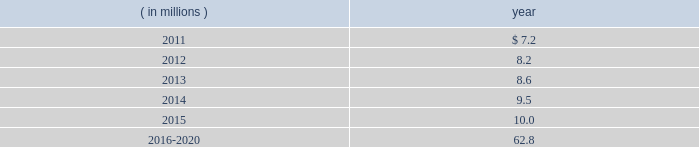The company expects to amortize $ 1.7 million of actuarial loss from accumulated other comprehensive income ( loss ) into net periodic benefit costs in 2011 .
At december 31 , 2010 , anticipated benefit payments from the plan in future years are as follows: .
Savings plans .
Cme maintains a defined contribution savings plan pursuant to section 401 ( k ) of the internal revenue code , whereby all u.s .
Employees are participants and have the option to contribute to this plan .
Cme matches employee contributions up to 3% ( 3 % ) of the employee 2019s base salary and may make additional discretionary contributions of up to 2% ( 2 % ) of base salary .
In addition , certain cme london-based employees are eligible to participate in a defined contribution plan .
For cme london-based employees , the plan provides for company contributions of 10% ( 10 % ) of earnings and does not have any vesting requirements .
Salary and cash bonuses paid are included in the definition of earnings .
Aggregate expense for all of the defined contribution savings plans amounted to $ 6.3 million , $ 5.2 million and $ 5.8 million in 2010 , 2009 and 2008 , respectively .
Cme non-qualified plans .
Cme maintains non-qualified plans , under which participants may make assumed investment choices with respect to amounts contributed on their behalf .
Although not required to do so , cme invests such contributions in assets that mirror the assumed investment choices .
The balances in these plans are subject to the claims of general creditors of the exchange and totaled $ 28.8 million and $ 23.4 million at december 31 , 2010 and 2009 , respectively .
Although the value of the plans is recorded as an asset in the consolidated balance sheets , there is an equal and offsetting liability .
The investment results of these plans have no impact on net income as the investment results are recorded in equal amounts to both investment income and compensation and benefits expense .
Supplemental savings plan 2014cme maintains a supplemental plan to provide benefits for employees who have been impacted by statutory limits under the provisions of the qualified pension and savings plan .
All cme employees hired prior to january 1 , 2007 are immediately vested in their supplemental plan benefits .
All cme employees hired on or after january 1 , 2007 are subject to the vesting requirements of the underlying qualified plans .
Total expense for the supplemental plan was $ 0.9 million , $ 0.7 million and $ 1.3 million for 2010 , 2009 and 2008 , respectively .
Deferred compensation plan 2014a deferred compensation plan is maintained by cme , under which eligible officers and members of the board of directors may contribute a percentage of their compensation and defer income taxes thereon until the time of distribution .
Nymexmembers 2019 retirement plan and benefits .
Nymex maintained a retirement and benefit plan under the commodities exchange , inc .
( comex ) members 2019 recognition and retention plan ( mrrp ) .
This plan provides benefits to certain members of the comex division based on long-term membership , and participation is limited to individuals who were comex division members prior to nymex 2019s acquisition of comex in 1994 .
No new participants were permitted into the plan after the date of this acquisition .
Under the terms of the mrrp , the company is required to fund the plan with a minimum annual contribution of $ 0.4 million until it is fully funded .
All benefits to be paid under the mrrp are based on reasonable actuarial assumptions which are based upon the amounts that are available and are expected to be available to pay benefits .
Total contributions to the plan were $ 0.8 million for each of 2010 , 2009 and for the period august 23 through december 31 , 2008 .
At december 31 , 2010 and 2009 , the total obligation for the mrrp totaled $ 20.7 million and $ 20.5 million .
Assuming an average contribution rate of 3% ( 3 % ) of earnings for defined contribution savings plans , what is the deemed aggregate compensation expense in millions in 2010? 
Computations: (6.3 / 3%)
Answer: 210.0. 